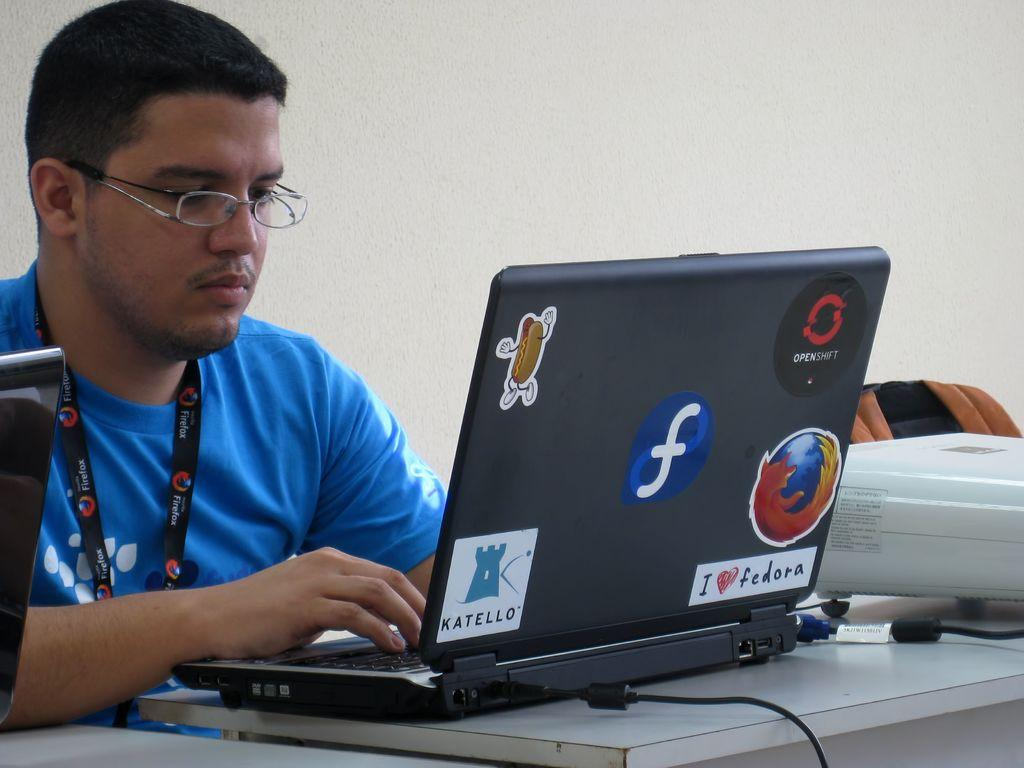<image>
Offer a succinct explanation of the picture presented. A man in a blue shirt is typing on a computer which has a sticker taped to the back that reads I love Fedora. 